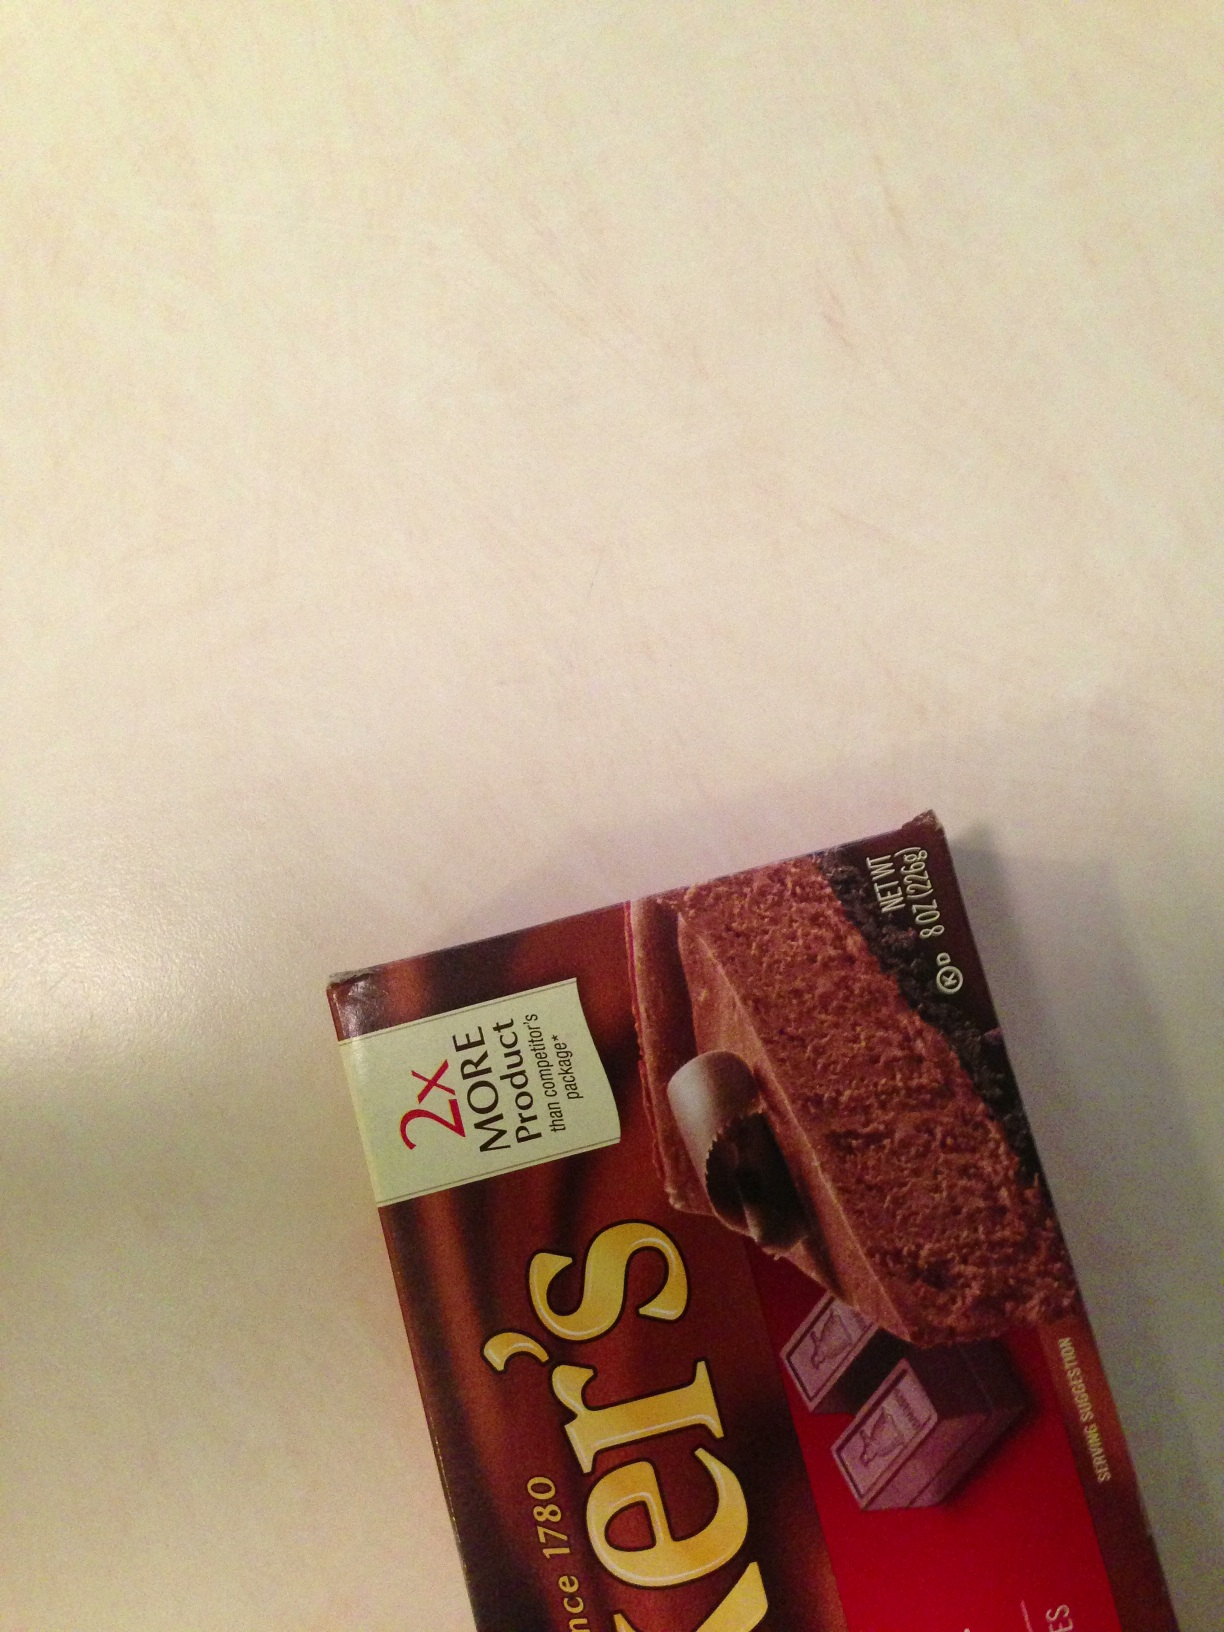Describe the packaging of this chocolate in detail. The packaging of Baker's Unsweetened Chocolate is designed to stand out on the shelves. The front of the package prominently features the brand name 'Baker's' in bold, golden letters, set against a rich brown background. Just below the brand name, there is an image of chocolate squares and a piece of chocolate being grated, suggesting its primary use in baking. The packaging also boasts 'Since 1780', highlighting its long-standing history. In the upper left corner, a label indicates '2X MORE Product' compared to competitor packages. The weight, '8 OZ (226g)', is specified on the lower right corner, and the package emphasizes that it contains 'Unsweetened Chocolate'. The overall design conveys a sense of tradition and quality, appealing to both amateur and professional bakers. What are some other products that complement unsweetened chocolate in baking? Other products that complement unsweetened chocolate in baking include:
1. **Sugar:** Balances the bitterness of unsweetened chocolate and adds sweetness to desserts.
2. **Butter:** Adds richness and creaminess to the texture of baked goods.
3. **Vanilla Extract:** Enhances the flavor profile of chocolate with its sweet, aromatic essence.
4. **Flour:** Provides structure to cakes, brownies, and other baked items.
5. **Eggs:** Help bind ingredients together and add moisture.
6. **Nuts:** Add a crunchy texture and a complementary nutty flavor to chocolate desserts.
7. **Cream:** Can be used to make smooth, chocolate ganache or frosting.
8. **Fruits:** Fresh or dried fruits like raspberries or cherries pair well with the rich flavor of chocolate.
9. **Baking Powder/Soda:** Help baked goods rise and achieve the desired texture. Describe how this chocolate can be used in a savory dish. Unsweetened chocolate can be used in savory dishes to add depth and a rich, complex flavor. One classic example is its use in mole sauce, a traditional Mexican sauce. Here’s how it can be used:

**Mole Sauce Recipe**

**Ingredients:**
- 2 tbsp olive oil
- 1 onion, finely chopped
- 3 cloves garlic, minced
- 2-3 dried ancho chilies, deseeded and chopped
- 1/4 cup almonds
- 1/4 cup raisins
- 1 tsp cumin
- 1 tsp cinnamon
- 1/2 tsp cayenne pepper
- 1 can (14 oz) diced tomatoes
- 2 cups chicken broth
- 1 oz Baker’s unsweetened chocolate, chopped
- Salt and pepper to taste

**Instructions:**
1. Heat olive oil in a large pan over medium heat. Add the chopped onion and garlic, and sauté until soft and golden.
2. Add the dried chilies, almonds, and raisins, and cook for a few minutes until the almonds are toasted.
3. Stir in the cumin, cinnamon, and cayenne pepper, and cook for another minute until fragrant.
4. Add the diced tomatoes and chicken broth, and bring to a boil. Reduce heat and let it simmer for about 20 minutes.
5. Remove from heat and carefully transfer the mixture to a blender. Blend until smooth and return to the pan.
6. Stir in the chopped unsweetened chocolate until melted and well combined. Season with salt and pepper to taste.
7. Serve the mole sauce over chicken, turkey, or vegetables, and enjoy the rich, savory chocolate-enhanced flavors. 